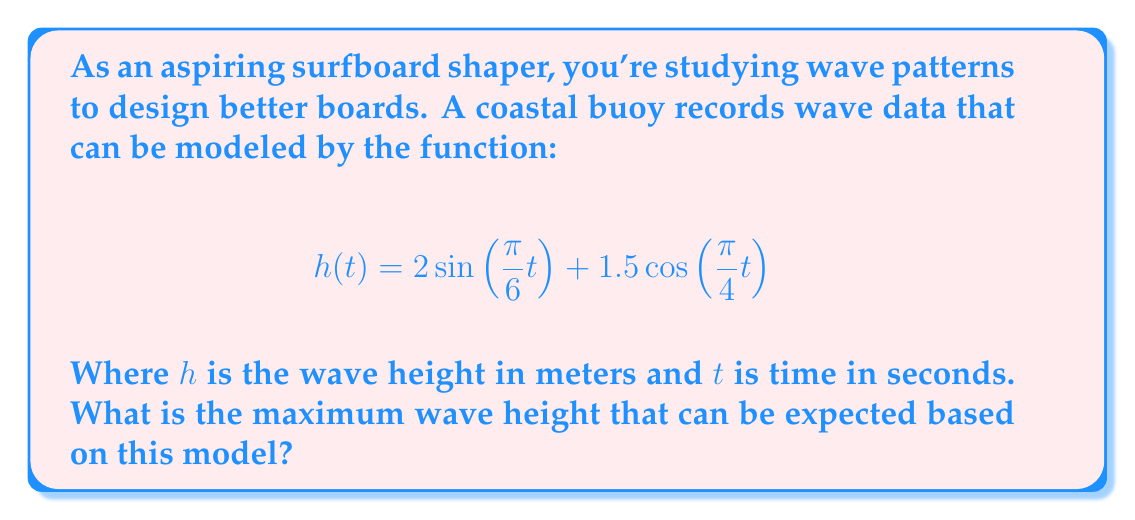Could you help me with this problem? To find the maximum wave height, we need to analyze the given trigonometric function:

$$h(t) = 2\sin(\frac{\pi}{6}t) + 1.5\cos(\frac{\pi}{4}t)$$

This is a sum of two trigonometric functions. To find the maximum possible value, we need to consider the maximum possible values of each component:

1. For the sine component: $2\sin(\frac{\pi}{6}t)$
   The maximum value of sine is 1, so the maximum value of this component is 2.

2. For the cosine component: $1.5\cos(\frac{\pi}{4}t)$
   The maximum value of cosine is also 1, so the maximum value of this component is 1.5.

The maximum possible value of the sum occurs when both components reach their maximum simultaneously. Therefore, the maximum wave height is the sum of these maximum values:

$$h_{max} = 2 + 1.5 = 3.5$$

It's important to note that this maximum might not actually occur in practice, as the sine and cosine functions might not reach their peaks at the same time. However, this represents the theoretical maximum based on the given model.
Answer: The maximum wave height that can be expected based on this model is 3.5 meters. 